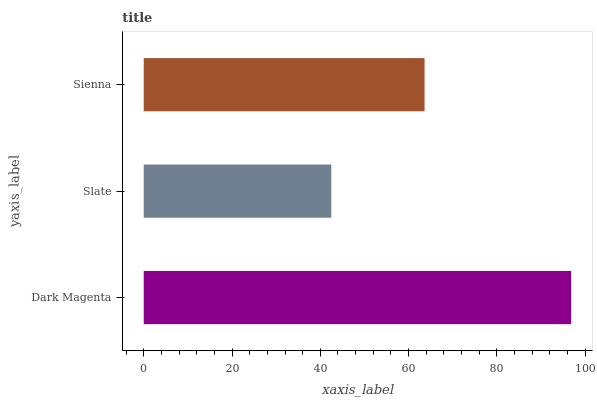Is Slate the minimum?
Answer yes or no. Yes. Is Dark Magenta the maximum?
Answer yes or no. Yes. Is Sienna the minimum?
Answer yes or no. No. Is Sienna the maximum?
Answer yes or no. No. Is Sienna greater than Slate?
Answer yes or no. Yes. Is Slate less than Sienna?
Answer yes or no. Yes. Is Slate greater than Sienna?
Answer yes or no. No. Is Sienna less than Slate?
Answer yes or no. No. Is Sienna the high median?
Answer yes or no. Yes. Is Sienna the low median?
Answer yes or no. Yes. Is Slate the high median?
Answer yes or no. No. Is Dark Magenta the low median?
Answer yes or no. No. 